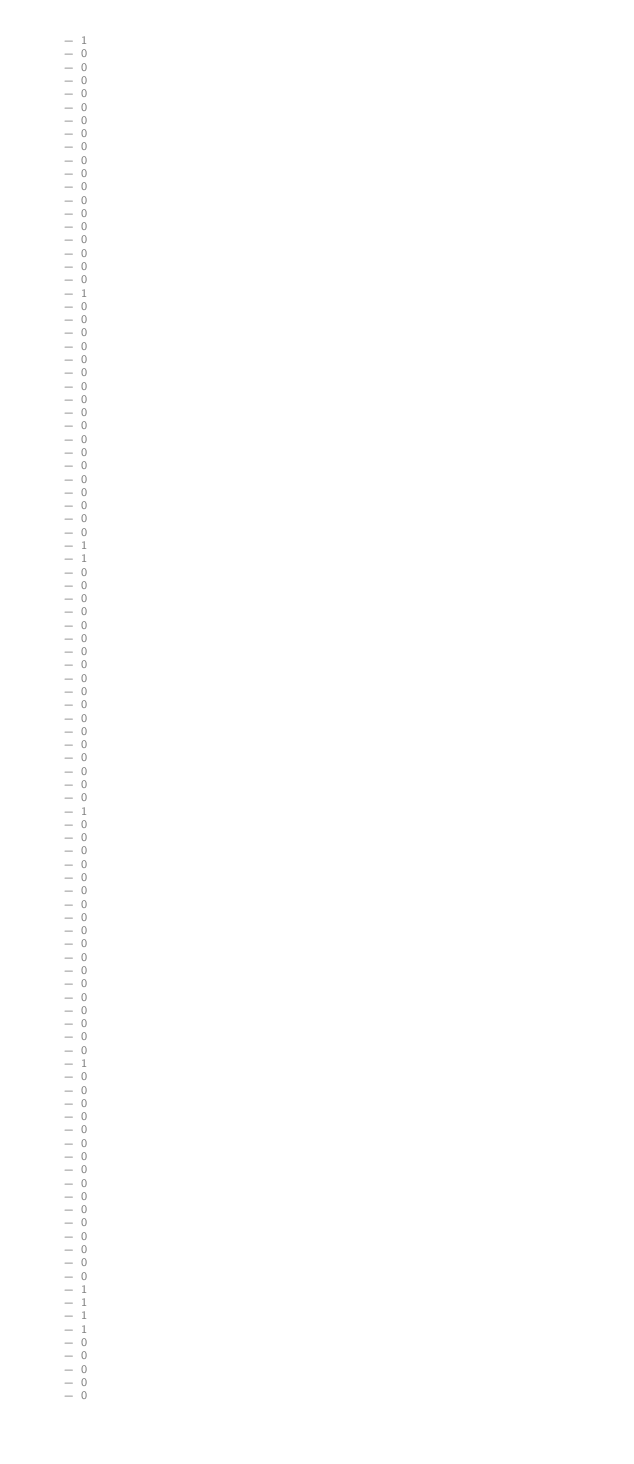<code> <loc_0><loc_0><loc_500><loc_500><_YAML_>    - 1
    - 0
    - 0
    - 0
    - 0
    - 0
    - 0
    - 0
    - 0
    - 0
    - 0
    - 0
    - 0
    - 0
    - 0
    - 0
    - 0
    - 0
    - 0
    - 1
    - 0
    - 0
    - 0
    - 0
    - 0
    - 0
    - 0
    - 0
    - 0
    - 0
    - 0
    - 0
    - 0
    - 0
    - 0
    - 0
    - 0
    - 0
    - 1
    - 1
    - 0
    - 0
    - 0
    - 0
    - 0
    - 0
    - 0
    - 0
    - 0
    - 0
    - 0
    - 0
    - 0
    - 0
    - 0
    - 0
    - 0
    - 0
    - 1
    - 0
    - 0
    - 0
    - 0
    - 0
    - 0
    - 0
    - 0
    - 0
    - 0
    - 0
    - 0
    - 0
    - 0
    - 0
    - 0
    - 0
    - 0
    - 1
    - 0
    - 0
    - 0
    - 0
    - 0
    - 0
    - 0
    - 0
    - 0
    - 0
    - 0
    - 0
    - 0
    - 0
    - 0
    - 0
    - 1
    - 1
    - 1
    - 1
    - 0
    - 0
    - 0
    - 0
    - 0</code> 